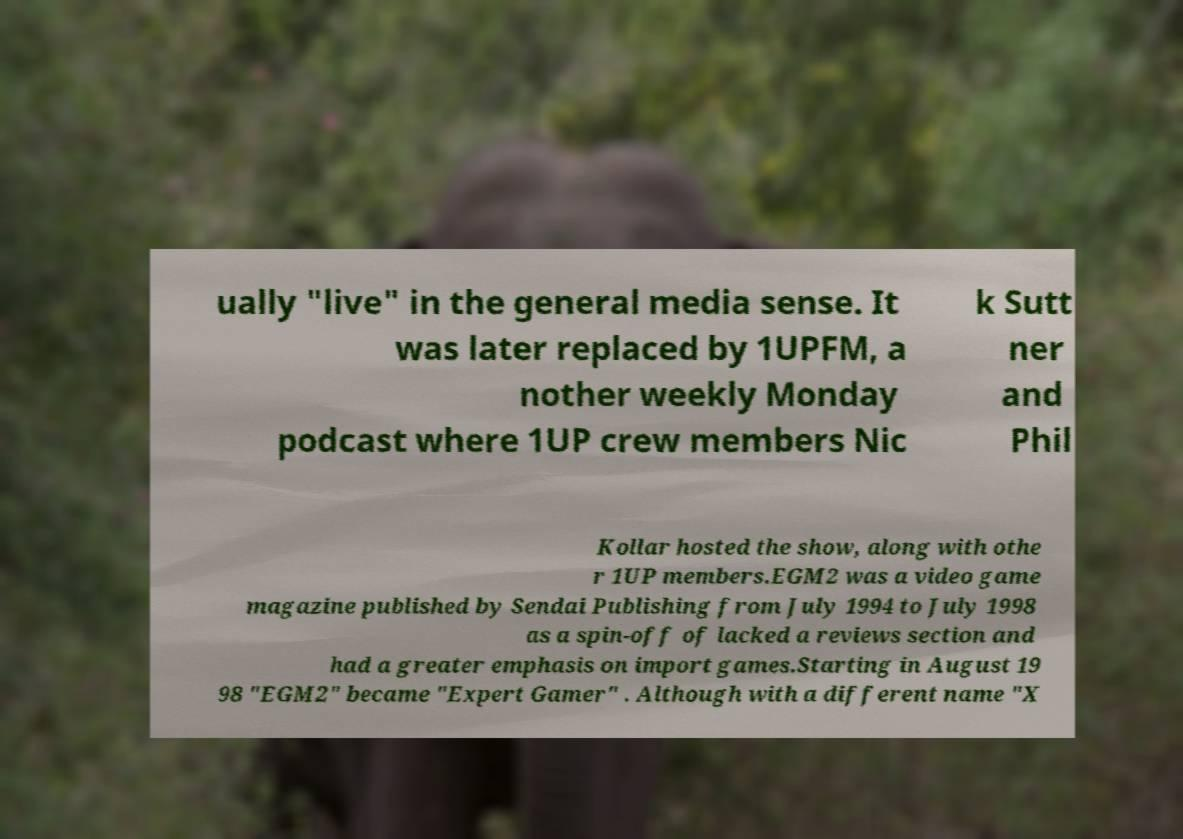There's text embedded in this image that I need extracted. Can you transcribe it verbatim? ually "live" in the general media sense. It was later replaced by 1UPFM, a nother weekly Monday podcast where 1UP crew members Nic k Sutt ner and Phil Kollar hosted the show, along with othe r 1UP members.EGM2 was a video game magazine published by Sendai Publishing from July 1994 to July 1998 as a spin-off of lacked a reviews section and had a greater emphasis on import games.Starting in August 19 98 "EGM2" became "Expert Gamer" . Although with a different name "X 